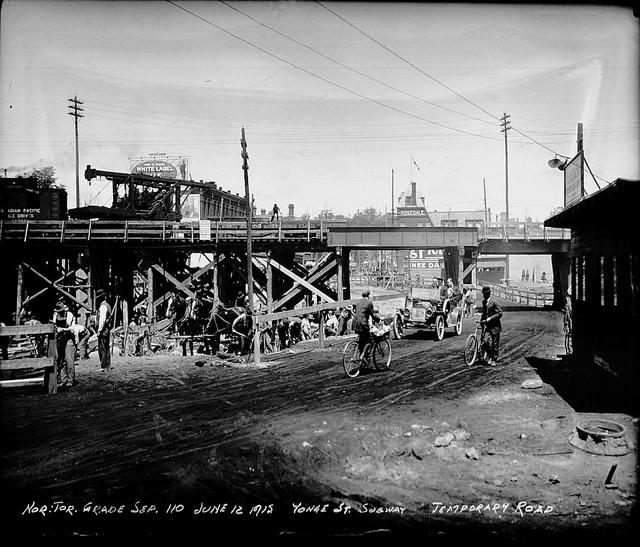What is near the car? bridge 